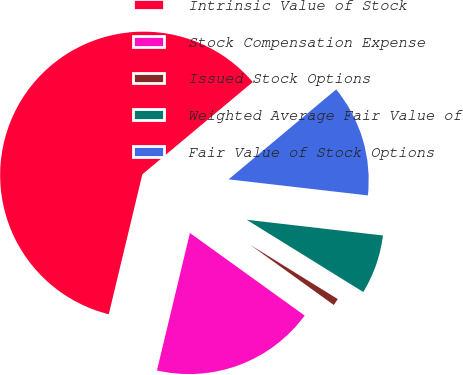Convert chart to OTSL. <chart><loc_0><loc_0><loc_500><loc_500><pie_chart><fcel>Intrinsic Value of Stock<fcel>Stock Compensation Expense<fcel>Issued Stock Options<fcel>Weighted Average Fair Value of<fcel>Fair Value of Stock Options<nl><fcel>60.17%<fcel>18.82%<fcel>1.1%<fcel>7.0%<fcel>12.91%<nl></chart> 